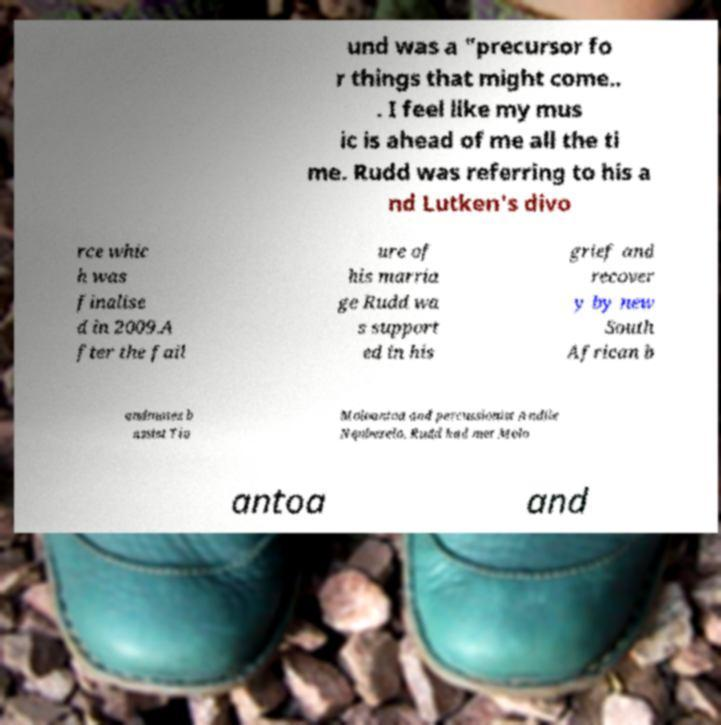What messages or text are displayed in this image? I need them in a readable, typed format. und was a "precursor fo r things that might come.. . I feel like my mus ic is ahead of me all the ti me. Rudd was referring to his a nd Lutken's divo rce whic h was finalise d in 2009.A fter the fail ure of his marria ge Rudd wa s support ed in his grief and recover y by new South African b andmates b assist Tio Moloantoa and percussionist Andile Nqubezelo. Rudd had met Molo antoa and 